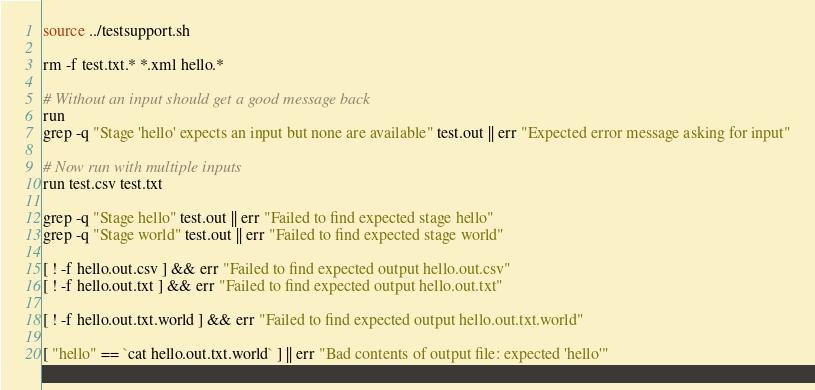<code> <loc_0><loc_0><loc_500><loc_500><_Bash_>source ../testsupport.sh

rm -f test.txt.* *.xml hello.*

# Without an input should get a good message back
run 
grep -q "Stage 'hello' expects an input but none are available" test.out || err "Expected error message asking for input"

# Now run with multiple inputs
run test.csv test.txt

grep -q "Stage hello" test.out || err "Failed to find expected stage hello"
grep -q "Stage world" test.out || err "Failed to find expected stage world"

[ ! -f hello.out.csv ] && err "Failed to find expected output hello.out.csv"
[ ! -f hello.out.txt ] && err "Failed to find expected output hello.out.txt"

[ ! -f hello.out.txt.world ] && err "Failed to find expected output hello.out.txt.world"

[ "hello" == `cat hello.out.txt.world` ] || err "Bad contents of output file: expected 'hello'"
</code> 